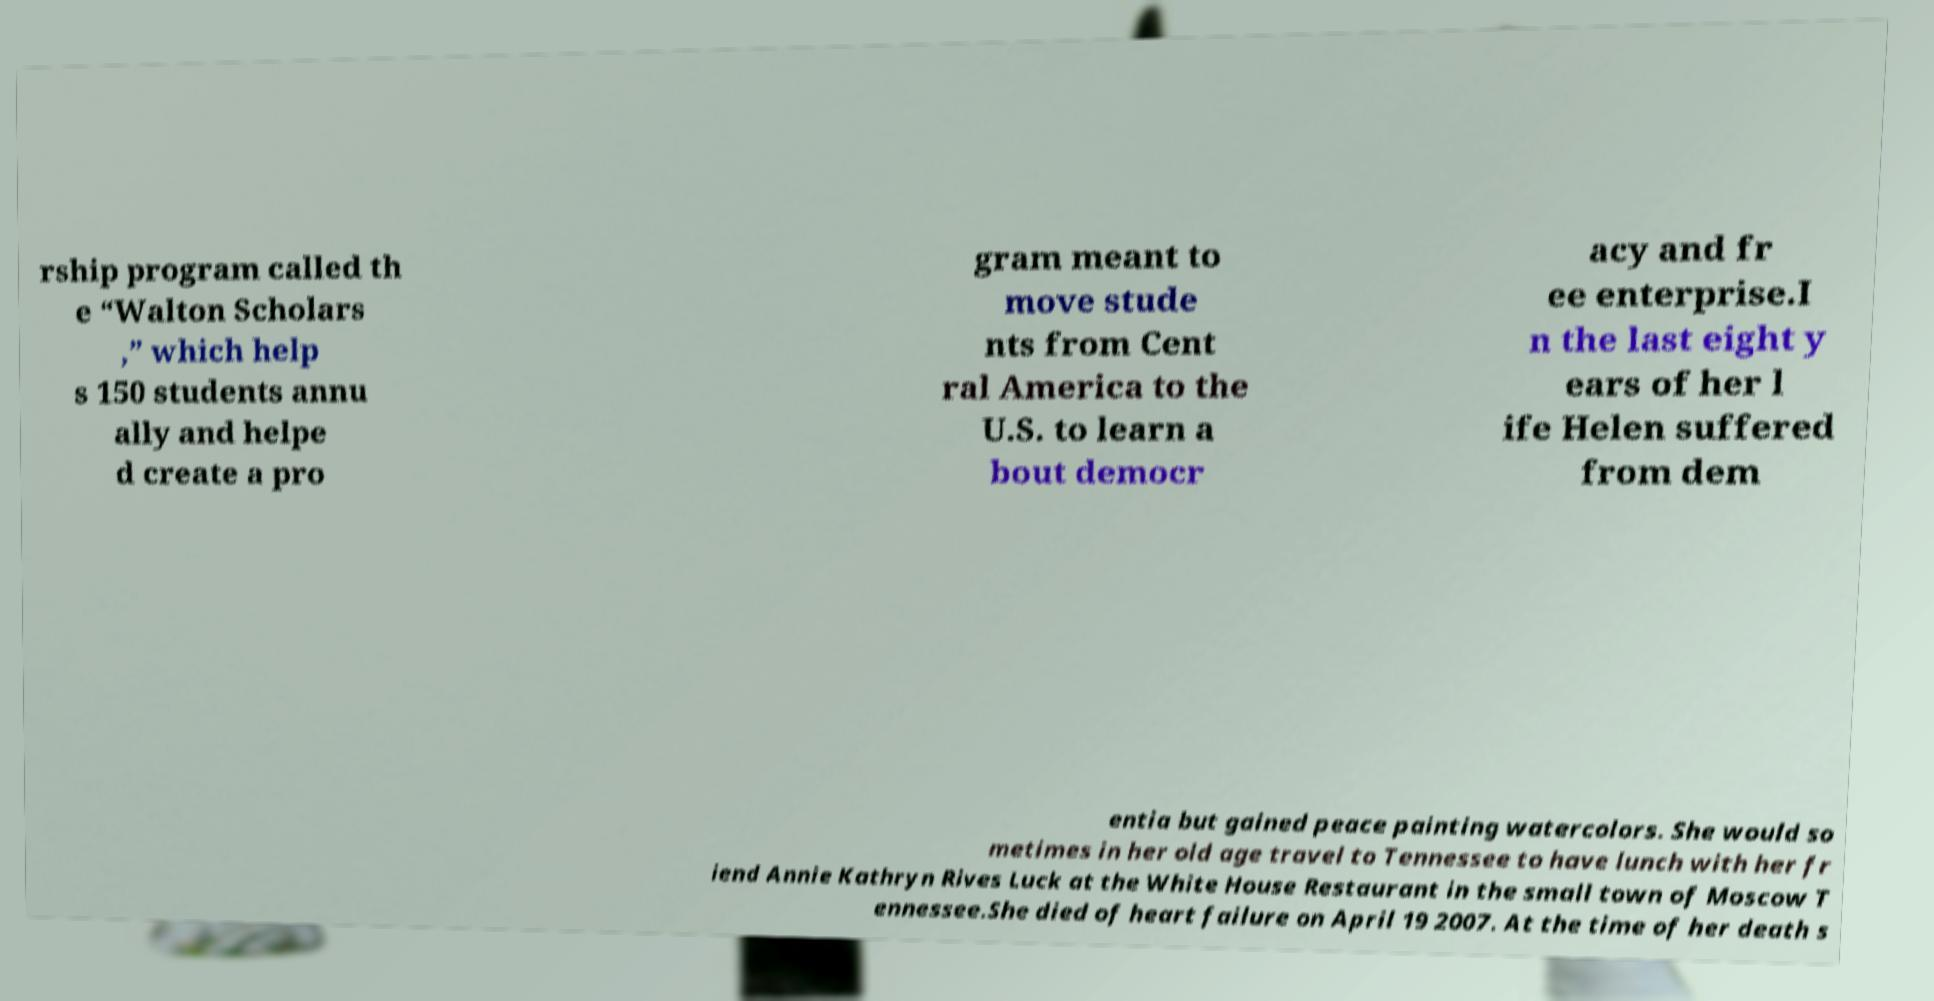Could you extract and type out the text from this image? rship program called th e “Walton Scholars ,” which help s 150 students annu ally and helpe d create a pro gram meant to move stude nts from Cent ral America to the U.S. to learn a bout democr acy and fr ee enterprise.I n the last eight y ears of her l ife Helen suffered from dem entia but gained peace painting watercolors. She would so metimes in her old age travel to Tennessee to have lunch with her fr iend Annie Kathryn Rives Luck at the White House Restaurant in the small town of Moscow T ennessee.She died of heart failure on April 19 2007. At the time of her death s 